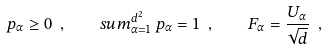<formula> <loc_0><loc_0><loc_500><loc_500>p _ { \alpha } \geq 0 \ , \quad s u m _ { \alpha = 1 } ^ { d ^ { 2 } } \, p _ { \alpha } = 1 \ , \quad F _ { \alpha } = \frac { U _ { \alpha } } { \sqrt { d } } \ ,</formula> 